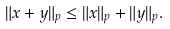Convert formula to latex. <formula><loc_0><loc_0><loc_500><loc_500>\| x + y \| _ { p } \leq \| x \| _ { p } + \| y \| _ { p } .</formula> 